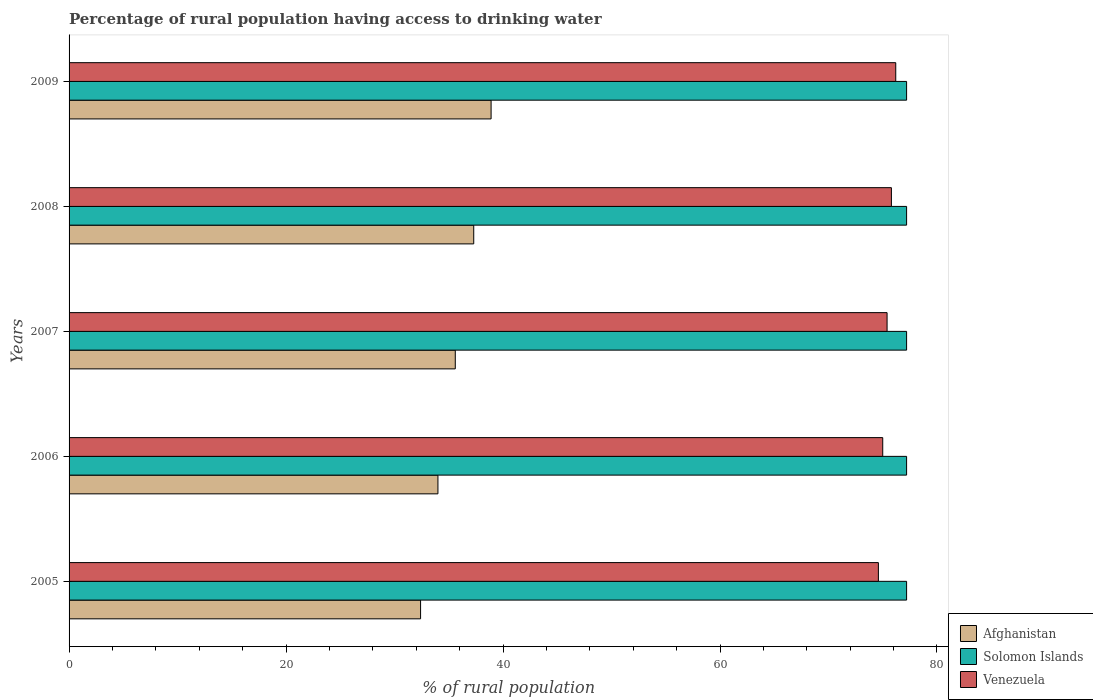Are the number of bars per tick equal to the number of legend labels?
Keep it short and to the point. Yes. Are the number of bars on each tick of the Y-axis equal?
Provide a succinct answer. Yes. How many bars are there on the 5th tick from the top?
Provide a succinct answer. 3. How many bars are there on the 4th tick from the bottom?
Your response must be concise. 3. What is the label of the 4th group of bars from the top?
Ensure brevity in your answer.  2006. In how many cases, is the number of bars for a given year not equal to the number of legend labels?
Make the answer very short. 0. What is the percentage of rural population having access to drinking water in Solomon Islands in 2006?
Make the answer very short. 77.2. Across all years, what is the maximum percentage of rural population having access to drinking water in Venezuela?
Offer a very short reply. 76.2. Across all years, what is the minimum percentage of rural population having access to drinking water in Afghanistan?
Keep it short and to the point. 32.4. In which year was the percentage of rural population having access to drinking water in Venezuela minimum?
Keep it short and to the point. 2005. What is the total percentage of rural population having access to drinking water in Venezuela in the graph?
Make the answer very short. 377. What is the difference between the percentage of rural population having access to drinking water in Afghanistan in 2008 and the percentage of rural population having access to drinking water in Venezuela in 2007?
Make the answer very short. -38.1. What is the average percentage of rural population having access to drinking water in Venezuela per year?
Ensure brevity in your answer.  75.4. In the year 2008, what is the difference between the percentage of rural population having access to drinking water in Solomon Islands and percentage of rural population having access to drinking water in Venezuela?
Your answer should be compact. 1.4. What is the ratio of the percentage of rural population having access to drinking water in Afghanistan in 2005 to that in 2008?
Provide a succinct answer. 0.87. Is the percentage of rural population having access to drinking water in Afghanistan in 2008 less than that in 2009?
Keep it short and to the point. Yes. Is the difference between the percentage of rural population having access to drinking water in Solomon Islands in 2006 and 2009 greater than the difference between the percentage of rural population having access to drinking water in Venezuela in 2006 and 2009?
Provide a succinct answer. Yes. What is the difference between the highest and the second highest percentage of rural population having access to drinking water in Venezuela?
Make the answer very short. 0.4. What is the difference between the highest and the lowest percentage of rural population having access to drinking water in Solomon Islands?
Your response must be concise. 0. Is the sum of the percentage of rural population having access to drinking water in Afghanistan in 2007 and 2008 greater than the maximum percentage of rural population having access to drinking water in Solomon Islands across all years?
Ensure brevity in your answer.  No. What does the 2nd bar from the top in 2009 represents?
Keep it short and to the point. Solomon Islands. What does the 1st bar from the bottom in 2006 represents?
Your answer should be very brief. Afghanistan. What is the difference between two consecutive major ticks on the X-axis?
Provide a succinct answer. 20. Are the values on the major ticks of X-axis written in scientific E-notation?
Make the answer very short. No. Does the graph contain any zero values?
Your response must be concise. No. Does the graph contain grids?
Provide a succinct answer. No. How are the legend labels stacked?
Ensure brevity in your answer.  Vertical. What is the title of the graph?
Provide a short and direct response. Percentage of rural population having access to drinking water. Does "Denmark" appear as one of the legend labels in the graph?
Offer a terse response. No. What is the label or title of the X-axis?
Provide a short and direct response. % of rural population. What is the % of rural population in Afghanistan in 2005?
Offer a very short reply. 32.4. What is the % of rural population in Solomon Islands in 2005?
Your answer should be very brief. 77.2. What is the % of rural population of Venezuela in 2005?
Provide a succinct answer. 74.6. What is the % of rural population of Afghanistan in 2006?
Your answer should be compact. 34. What is the % of rural population of Solomon Islands in 2006?
Provide a succinct answer. 77.2. What is the % of rural population in Venezuela in 2006?
Provide a short and direct response. 75. What is the % of rural population in Afghanistan in 2007?
Your answer should be compact. 35.6. What is the % of rural population in Solomon Islands in 2007?
Make the answer very short. 77.2. What is the % of rural population of Venezuela in 2007?
Your answer should be compact. 75.4. What is the % of rural population in Afghanistan in 2008?
Ensure brevity in your answer.  37.3. What is the % of rural population of Solomon Islands in 2008?
Offer a terse response. 77.2. What is the % of rural population of Venezuela in 2008?
Your answer should be compact. 75.8. What is the % of rural population in Afghanistan in 2009?
Keep it short and to the point. 38.9. What is the % of rural population in Solomon Islands in 2009?
Your answer should be compact. 77.2. What is the % of rural population of Venezuela in 2009?
Keep it short and to the point. 76.2. Across all years, what is the maximum % of rural population in Afghanistan?
Offer a terse response. 38.9. Across all years, what is the maximum % of rural population of Solomon Islands?
Offer a terse response. 77.2. Across all years, what is the maximum % of rural population in Venezuela?
Offer a very short reply. 76.2. Across all years, what is the minimum % of rural population of Afghanistan?
Your answer should be compact. 32.4. Across all years, what is the minimum % of rural population of Solomon Islands?
Give a very brief answer. 77.2. Across all years, what is the minimum % of rural population in Venezuela?
Make the answer very short. 74.6. What is the total % of rural population of Afghanistan in the graph?
Provide a succinct answer. 178.2. What is the total % of rural population in Solomon Islands in the graph?
Offer a terse response. 386. What is the total % of rural population in Venezuela in the graph?
Your answer should be compact. 377. What is the difference between the % of rural population in Solomon Islands in 2005 and that in 2007?
Provide a short and direct response. 0. What is the difference between the % of rural population of Venezuela in 2005 and that in 2007?
Offer a very short reply. -0.8. What is the difference between the % of rural population in Afghanistan in 2005 and that in 2008?
Offer a very short reply. -4.9. What is the difference between the % of rural population in Venezuela in 2005 and that in 2008?
Give a very brief answer. -1.2. What is the difference between the % of rural population of Afghanistan in 2005 and that in 2009?
Ensure brevity in your answer.  -6.5. What is the difference between the % of rural population in Afghanistan in 2006 and that in 2007?
Offer a terse response. -1.6. What is the difference between the % of rural population of Solomon Islands in 2006 and that in 2008?
Keep it short and to the point. 0. What is the difference between the % of rural population of Venezuela in 2006 and that in 2008?
Give a very brief answer. -0.8. What is the difference between the % of rural population of Afghanistan in 2006 and that in 2009?
Provide a succinct answer. -4.9. What is the difference between the % of rural population of Venezuela in 2006 and that in 2009?
Offer a terse response. -1.2. What is the difference between the % of rural population in Afghanistan in 2007 and that in 2008?
Offer a terse response. -1.7. What is the difference between the % of rural population in Solomon Islands in 2007 and that in 2008?
Your answer should be compact. 0. What is the difference between the % of rural population in Solomon Islands in 2007 and that in 2009?
Offer a very short reply. 0. What is the difference between the % of rural population of Afghanistan in 2005 and the % of rural population of Solomon Islands in 2006?
Provide a succinct answer. -44.8. What is the difference between the % of rural population in Afghanistan in 2005 and the % of rural population in Venezuela in 2006?
Your answer should be compact. -42.6. What is the difference between the % of rural population of Solomon Islands in 2005 and the % of rural population of Venezuela in 2006?
Ensure brevity in your answer.  2.2. What is the difference between the % of rural population in Afghanistan in 2005 and the % of rural population in Solomon Islands in 2007?
Ensure brevity in your answer.  -44.8. What is the difference between the % of rural population of Afghanistan in 2005 and the % of rural population of Venezuela in 2007?
Provide a succinct answer. -43. What is the difference between the % of rural population in Afghanistan in 2005 and the % of rural population in Solomon Islands in 2008?
Make the answer very short. -44.8. What is the difference between the % of rural population of Afghanistan in 2005 and the % of rural population of Venezuela in 2008?
Offer a terse response. -43.4. What is the difference between the % of rural population in Afghanistan in 2005 and the % of rural population in Solomon Islands in 2009?
Make the answer very short. -44.8. What is the difference between the % of rural population of Afghanistan in 2005 and the % of rural population of Venezuela in 2009?
Provide a short and direct response. -43.8. What is the difference between the % of rural population in Solomon Islands in 2005 and the % of rural population in Venezuela in 2009?
Give a very brief answer. 1. What is the difference between the % of rural population of Afghanistan in 2006 and the % of rural population of Solomon Islands in 2007?
Ensure brevity in your answer.  -43.2. What is the difference between the % of rural population in Afghanistan in 2006 and the % of rural population in Venezuela in 2007?
Keep it short and to the point. -41.4. What is the difference between the % of rural population in Solomon Islands in 2006 and the % of rural population in Venezuela in 2007?
Give a very brief answer. 1.8. What is the difference between the % of rural population in Afghanistan in 2006 and the % of rural population in Solomon Islands in 2008?
Make the answer very short. -43.2. What is the difference between the % of rural population in Afghanistan in 2006 and the % of rural population in Venezuela in 2008?
Your answer should be compact. -41.8. What is the difference between the % of rural population in Afghanistan in 2006 and the % of rural population in Solomon Islands in 2009?
Offer a very short reply. -43.2. What is the difference between the % of rural population in Afghanistan in 2006 and the % of rural population in Venezuela in 2009?
Ensure brevity in your answer.  -42.2. What is the difference between the % of rural population of Afghanistan in 2007 and the % of rural population of Solomon Islands in 2008?
Your answer should be very brief. -41.6. What is the difference between the % of rural population of Afghanistan in 2007 and the % of rural population of Venezuela in 2008?
Provide a succinct answer. -40.2. What is the difference between the % of rural population of Afghanistan in 2007 and the % of rural population of Solomon Islands in 2009?
Your answer should be compact. -41.6. What is the difference between the % of rural population of Afghanistan in 2007 and the % of rural population of Venezuela in 2009?
Your answer should be compact. -40.6. What is the difference between the % of rural population of Afghanistan in 2008 and the % of rural population of Solomon Islands in 2009?
Provide a short and direct response. -39.9. What is the difference between the % of rural population of Afghanistan in 2008 and the % of rural population of Venezuela in 2009?
Give a very brief answer. -38.9. What is the average % of rural population in Afghanistan per year?
Offer a terse response. 35.64. What is the average % of rural population of Solomon Islands per year?
Your answer should be very brief. 77.2. What is the average % of rural population in Venezuela per year?
Keep it short and to the point. 75.4. In the year 2005, what is the difference between the % of rural population of Afghanistan and % of rural population of Solomon Islands?
Provide a short and direct response. -44.8. In the year 2005, what is the difference between the % of rural population in Afghanistan and % of rural population in Venezuela?
Keep it short and to the point. -42.2. In the year 2005, what is the difference between the % of rural population of Solomon Islands and % of rural population of Venezuela?
Provide a succinct answer. 2.6. In the year 2006, what is the difference between the % of rural population of Afghanistan and % of rural population of Solomon Islands?
Keep it short and to the point. -43.2. In the year 2006, what is the difference between the % of rural population of Afghanistan and % of rural population of Venezuela?
Offer a terse response. -41. In the year 2007, what is the difference between the % of rural population of Afghanistan and % of rural population of Solomon Islands?
Make the answer very short. -41.6. In the year 2007, what is the difference between the % of rural population in Afghanistan and % of rural population in Venezuela?
Ensure brevity in your answer.  -39.8. In the year 2007, what is the difference between the % of rural population of Solomon Islands and % of rural population of Venezuela?
Ensure brevity in your answer.  1.8. In the year 2008, what is the difference between the % of rural population of Afghanistan and % of rural population of Solomon Islands?
Give a very brief answer. -39.9. In the year 2008, what is the difference between the % of rural population of Afghanistan and % of rural population of Venezuela?
Ensure brevity in your answer.  -38.5. In the year 2008, what is the difference between the % of rural population of Solomon Islands and % of rural population of Venezuela?
Ensure brevity in your answer.  1.4. In the year 2009, what is the difference between the % of rural population of Afghanistan and % of rural population of Solomon Islands?
Offer a very short reply. -38.3. In the year 2009, what is the difference between the % of rural population of Afghanistan and % of rural population of Venezuela?
Offer a terse response. -37.3. In the year 2009, what is the difference between the % of rural population of Solomon Islands and % of rural population of Venezuela?
Give a very brief answer. 1. What is the ratio of the % of rural population in Afghanistan in 2005 to that in 2006?
Your response must be concise. 0.95. What is the ratio of the % of rural population in Solomon Islands in 2005 to that in 2006?
Keep it short and to the point. 1. What is the ratio of the % of rural population in Venezuela in 2005 to that in 2006?
Provide a succinct answer. 0.99. What is the ratio of the % of rural population of Afghanistan in 2005 to that in 2007?
Your answer should be very brief. 0.91. What is the ratio of the % of rural population in Solomon Islands in 2005 to that in 2007?
Your response must be concise. 1. What is the ratio of the % of rural population in Venezuela in 2005 to that in 2007?
Your answer should be compact. 0.99. What is the ratio of the % of rural population in Afghanistan in 2005 to that in 2008?
Your answer should be very brief. 0.87. What is the ratio of the % of rural population of Venezuela in 2005 to that in 2008?
Keep it short and to the point. 0.98. What is the ratio of the % of rural population of Afghanistan in 2005 to that in 2009?
Keep it short and to the point. 0.83. What is the ratio of the % of rural population of Solomon Islands in 2005 to that in 2009?
Keep it short and to the point. 1. What is the ratio of the % of rural population in Venezuela in 2005 to that in 2009?
Offer a very short reply. 0.98. What is the ratio of the % of rural population of Afghanistan in 2006 to that in 2007?
Your response must be concise. 0.96. What is the ratio of the % of rural population in Venezuela in 2006 to that in 2007?
Your response must be concise. 0.99. What is the ratio of the % of rural population of Afghanistan in 2006 to that in 2008?
Provide a succinct answer. 0.91. What is the ratio of the % of rural population in Solomon Islands in 2006 to that in 2008?
Your answer should be very brief. 1. What is the ratio of the % of rural population in Venezuela in 2006 to that in 2008?
Keep it short and to the point. 0.99. What is the ratio of the % of rural population in Afghanistan in 2006 to that in 2009?
Your answer should be very brief. 0.87. What is the ratio of the % of rural population in Solomon Islands in 2006 to that in 2009?
Your answer should be very brief. 1. What is the ratio of the % of rural population of Venezuela in 2006 to that in 2009?
Your response must be concise. 0.98. What is the ratio of the % of rural population in Afghanistan in 2007 to that in 2008?
Ensure brevity in your answer.  0.95. What is the ratio of the % of rural population of Solomon Islands in 2007 to that in 2008?
Provide a short and direct response. 1. What is the ratio of the % of rural population in Afghanistan in 2007 to that in 2009?
Ensure brevity in your answer.  0.92. What is the ratio of the % of rural population of Solomon Islands in 2007 to that in 2009?
Your answer should be very brief. 1. What is the ratio of the % of rural population of Afghanistan in 2008 to that in 2009?
Offer a very short reply. 0.96. What is the ratio of the % of rural population in Solomon Islands in 2008 to that in 2009?
Ensure brevity in your answer.  1. What is the ratio of the % of rural population of Venezuela in 2008 to that in 2009?
Make the answer very short. 0.99. What is the difference between the highest and the second highest % of rural population of Solomon Islands?
Keep it short and to the point. 0. What is the difference between the highest and the second highest % of rural population in Venezuela?
Provide a short and direct response. 0.4. What is the difference between the highest and the lowest % of rural population of Venezuela?
Give a very brief answer. 1.6. 